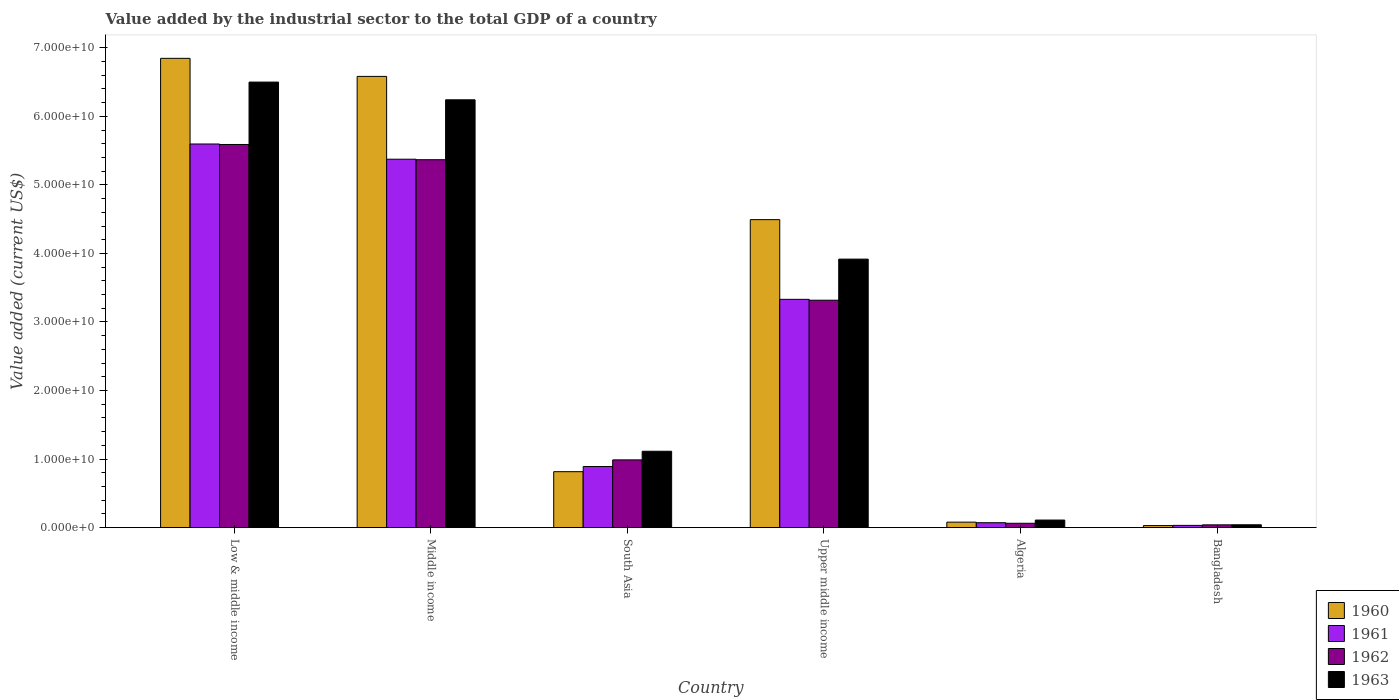How many groups of bars are there?
Offer a terse response. 6. Are the number of bars on each tick of the X-axis equal?
Offer a very short reply. Yes. How many bars are there on the 4th tick from the right?
Your answer should be compact. 4. What is the label of the 3rd group of bars from the left?
Offer a very short reply. South Asia. In how many cases, is the number of bars for a given country not equal to the number of legend labels?
Keep it short and to the point. 0. What is the value added by the industrial sector to the total GDP in 1960 in Algeria?
Provide a succinct answer. 8.00e+08. Across all countries, what is the maximum value added by the industrial sector to the total GDP in 1960?
Your answer should be very brief. 6.85e+1. Across all countries, what is the minimum value added by the industrial sector to the total GDP in 1963?
Keep it short and to the point. 4.15e+08. In which country was the value added by the industrial sector to the total GDP in 1963 maximum?
Provide a short and direct response. Low & middle income. What is the total value added by the industrial sector to the total GDP in 1963 in the graph?
Your answer should be very brief. 1.79e+11. What is the difference between the value added by the industrial sector to the total GDP in 1962 in Algeria and that in Upper middle income?
Provide a succinct answer. -3.25e+1. What is the difference between the value added by the industrial sector to the total GDP in 1963 in Upper middle income and the value added by the industrial sector to the total GDP in 1961 in Low & middle income?
Your answer should be compact. -1.68e+1. What is the average value added by the industrial sector to the total GDP in 1962 per country?
Make the answer very short. 2.56e+1. What is the difference between the value added by the industrial sector to the total GDP of/in 1961 and value added by the industrial sector to the total GDP of/in 1963 in South Asia?
Your answer should be compact. -2.23e+09. In how many countries, is the value added by the industrial sector to the total GDP in 1961 greater than 24000000000 US$?
Your answer should be very brief. 3. What is the ratio of the value added by the industrial sector to the total GDP in 1962 in Algeria to that in Upper middle income?
Provide a short and direct response. 0.02. Is the difference between the value added by the industrial sector to the total GDP in 1961 in Algeria and Middle income greater than the difference between the value added by the industrial sector to the total GDP in 1963 in Algeria and Middle income?
Make the answer very short. Yes. What is the difference between the highest and the second highest value added by the industrial sector to the total GDP in 1963?
Keep it short and to the point. 2.58e+1. What is the difference between the highest and the lowest value added by the industrial sector to the total GDP in 1960?
Your answer should be very brief. 6.82e+1. In how many countries, is the value added by the industrial sector to the total GDP in 1961 greater than the average value added by the industrial sector to the total GDP in 1961 taken over all countries?
Provide a succinct answer. 3. Is the sum of the value added by the industrial sector to the total GDP in 1961 in Algeria and Middle income greater than the maximum value added by the industrial sector to the total GDP in 1963 across all countries?
Offer a very short reply. No. Is it the case that in every country, the sum of the value added by the industrial sector to the total GDP in 1962 and value added by the industrial sector to the total GDP in 1961 is greater than the sum of value added by the industrial sector to the total GDP in 1960 and value added by the industrial sector to the total GDP in 1963?
Give a very brief answer. No. What does the 3rd bar from the right in Middle income represents?
Your answer should be very brief. 1961. How many bars are there?
Provide a succinct answer. 24. Are all the bars in the graph horizontal?
Provide a succinct answer. No. How many countries are there in the graph?
Provide a short and direct response. 6. Are the values on the major ticks of Y-axis written in scientific E-notation?
Keep it short and to the point. Yes. Does the graph contain grids?
Keep it short and to the point. No. Where does the legend appear in the graph?
Offer a very short reply. Bottom right. How many legend labels are there?
Offer a terse response. 4. How are the legend labels stacked?
Keep it short and to the point. Vertical. What is the title of the graph?
Your answer should be compact. Value added by the industrial sector to the total GDP of a country. What is the label or title of the X-axis?
Provide a succinct answer. Country. What is the label or title of the Y-axis?
Your answer should be compact. Value added (current US$). What is the Value added (current US$) of 1960 in Low & middle income?
Provide a short and direct response. 6.85e+1. What is the Value added (current US$) in 1961 in Low & middle income?
Give a very brief answer. 5.60e+1. What is the Value added (current US$) in 1962 in Low & middle income?
Provide a succinct answer. 5.59e+1. What is the Value added (current US$) of 1963 in Low & middle income?
Provide a succinct answer. 6.50e+1. What is the Value added (current US$) of 1960 in Middle income?
Your answer should be very brief. 6.58e+1. What is the Value added (current US$) in 1961 in Middle income?
Your response must be concise. 5.37e+1. What is the Value added (current US$) of 1962 in Middle income?
Make the answer very short. 5.37e+1. What is the Value added (current US$) in 1963 in Middle income?
Offer a very short reply. 6.24e+1. What is the Value added (current US$) of 1960 in South Asia?
Your answer should be compact. 8.16e+09. What is the Value added (current US$) in 1961 in South Asia?
Your answer should be compact. 8.91e+09. What is the Value added (current US$) in 1962 in South Asia?
Offer a very short reply. 9.88e+09. What is the Value added (current US$) of 1963 in South Asia?
Provide a short and direct response. 1.11e+1. What is the Value added (current US$) in 1960 in Upper middle income?
Your answer should be very brief. 4.49e+1. What is the Value added (current US$) of 1961 in Upper middle income?
Make the answer very short. 3.33e+1. What is the Value added (current US$) in 1962 in Upper middle income?
Make the answer very short. 3.32e+1. What is the Value added (current US$) in 1963 in Upper middle income?
Provide a succinct answer. 3.92e+1. What is the Value added (current US$) in 1960 in Algeria?
Your response must be concise. 8.00e+08. What is the Value added (current US$) of 1961 in Algeria?
Keep it short and to the point. 7.17e+08. What is the Value added (current US$) of 1962 in Algeria?
Your answer should be very brief. 6.34e+08. What is the Value added (current US$) in 1963 in Algeria?
Offer a terse response. 1.10e+09. What is the Value added (current US$) of 1960 in Bangladesh?
Offer a very short reply. 2.98e+08. What is the Value added (current US$) in 1961 in Bangladesh?
Your answer should be compact. 3.27e+08. What is the Value added (current US$) of 1962 in Bangladesh?
Provide a succinct answer. 4.05e+08. What is the Value added (current US$) of 1963 in Bangladesh?
Offer a very short reply. 4.15e+08. Across all countries, what is the maximum Value added (current US$) in 1960?
Provide a short and direct response. 6.85e+1. Across all countries, what is the maximum Value added (current US$) of 1961?
Give a very brief answer. 5.60e+1. Across all countries, what is the maximum Value added (current US$) in 1962?
Make the answer very short. 5.59e+1. Across all countries, what is the maximum Value added (current US$) in 1963?
Provide a short and direct response. 6.50e+1. Across all countries, what is the minimum Value added (current US$) of 1960?
Make the answer very short. 2.98e+08. Across all countries, what is the minimum Value added (current US$) in 1961?
Ensure brevity in your answer.  3.27e+08. Across all countries, what is the minimum Value added (current US$) of 1962?
Your answer should be very brief. 4.05e+08. Across all countries, what is the minimum Value added (current US$) in 1963?
Provide a succinct answer. 4.15e+08. What is the total Value added (current US$) in 1960 in the graph?
Your response must be concise. 1.88e+11. What is the total Value added (current US$) in 1961 in the graph?
Provide a succinct answer. 1.53e+11. What is the total Value added (current US$) in 1962 in the graph?
Your answer should be very brief. 1.54e+11. What is the total Value added (current US$) in 1963 in the graph?
Make the answer very short. 1.79e+11. What is the difference between the Value added (current US$) of 1960 in Low & middle income and that in Middle income?
Your response must be concise. 2.63e+09. What is the difference between the Value added (current US$) in 1961 in Low & middle income and that in Middle income?
Your answer should be very brief. 2.22e+09. What is the difference between the Value added (current US$) in 1962 in Low & middle income and that in Middle income?
Offer a terse response. 2.22e+09. What is the difference between the Value added (current US$) in 1963 in Low & middle income and that in Middle income?
Ensure brevity in your answer.  2.59e+09. What is the difference between the Value added (current US$) in 1960 in Low & middle income and that in South Asia?
Give a very brief answer. 6.03e+1. What is the difference between the Value added (current US$) of 1961 in Low & middle income and that in South Asia?
Keep it short and to the point. 4.71e+1. What is the difference between the Value added (current US$) of 1962 in Low & middle income and that in South Asia?
Provide a succinct answer. 4.60e+1. What is the difference between the Value added (current US$) in 1963 in Low & middle income and that in South Asia?
Provide a short and direct response. 5.39e+1. What is the difference between the Value added (current US$) of 1960 in Low & middle income and that in Upper middle income?
Offer a very short reply. 2.35e+1. What is the difference between the Value added (current US$) in 1961 in Low & middle income and that in Upper middle income?
Provide a short and direct response. 2.27e+1. What is the difference between the Value added (current US$) in 1962 in Low & middle income and that in Upper middle income?
Offer a very short reply. 2.27e+1. What is the difference between the Value added (current US$) in 1963 in Low & middle income and that in Upper middle income?
Provide a succinct answer. 2.58e+1. What is the difference between the Value added (current US$) of 1960 in Low & middle income and that in Algeria?
Ensure brevity in your answer.  6.77e+1. What is the difference between the Value added (current US$) in 1961 in Low & middle income and that in Algeria?
Offer a very short reply. 5.53e+1. What is the difference between the Value added (current US$) in 1962 in Low & middle income and that in Algeria?
Offer a very short reply. 5.53e+1. What is the difference between the Value added (current US$) in 1963 in Low & middle income and that in Algeria?
Provide a succinct answer. 6.39e+1. What is the difference between the Value added (current US$) of 1960 in Low & middle income and that in Bangladesh?
Your response must be concise. 6.82e+1. What is the difference between the Value added (current US$) of 1961 in Low & middle income and that in Bangladesh?
Provide a short and direct response. 5.56e+1. What is the difference between the Value added (current US$) of 1962 in Low & middle income and that in Bangladesh?
Offer a very short reply. 5.55e+1. What is the difference between the Value added (current US$) in 1963 in Low & middle income and that in Bangladesh?
Ensure brevity in your answer.  6.46e+1. What is the difference between the Value added (current US$) of 1960 in Middle income and that in South Asia?
Your answer should be compact. 5.77e+1. What is the difference between the Value added (current US$) of 1961 in Middle income and that in South Asia?
Your response must be concise. 4.48e+1. What is the difference between the Value added (current US$) in 1962 in Middle income and that in South Asia?
Provide a short and direct response. 4.38e+1. What is the difference between the Value added (current US$) of 1963 in Middle income and that in South Asia?
Keep it short and to the point. 5.13e+1. What is the difference between the Value added (current US$) in 1960 in Middle income and that in Upper middle income?
Provide a succinct answer. 2.09e+1. What is the difference between the Value added (current US$) of 1961 in Middle income and that in Upper middle income?
Offer a terse response. 2.04e+1. What is the difference between the Value added (current US$) in 1962 in Middle income and that in Upper middle income?
Ensure brevity in your answer.  2.05e+1. What is the difference between the Value added (current US$) of 1963 in Middle income and that in Upper middle income?
Offer a very short reply. 2.32e+1. What is the difference between the Value added (current US$) in 1960 in Middle income and that in Algeria?
Offer a terse response. 6.50e+1. What is the difference between the Value added (current US$) in 1961 in Middle income and that in Algeria?
Provide a succinct answer. 5.30e+1. What is the difference between the Value added (current US$) of 1962 in Middle income and that in Algeria?
Give a very brief answer. 5.30e+1. What is the difference between the Value added (current US$) in 1963 in Middle income and that in Algeria?
Give a very brief answer. 6.13e+1. What is the difference between the Value added (current US$) in 1960 in Middle income and that in Bangladesh?
Provide a succinct answer. 6.55e+1. What is the difference between the Value added (current US$) in 1961 in Middle income and that in Bangladesh?
Offer a terse response. 5.34e+1. What is the difference between the Value added (current US$) of 1962 in Middle income and that in Bangladesh?
Your answer should be very brief. 5.33e+1. What is the difference between the Value added (current US$) of 1963 in Middle income and that in Bangladesh?
Your response must be concise. 6.20e+1. What is the difference between the Value added (current US$) of 1960 in South Asia and that in Upper middle income?
Your answer should be very brief. -3.68e+1. What is the difference between the Value added (current US$) of 1961 in South Asia and that in Upper middle income?
Give a very brief answer. -2.44e+1. What is the difference between the Value added (current US$) in 1962 in South Asia and that in Upper middle income?
Your answer should be compact. -2.33e+1. What is the difference between the Value added (current US$) of 1963 in South Asia and that in Upper middle income?
Ensure brevity in your answer.  -2.80e+1. What is the difference between the Value added (current US$) of 1960 in South Asia and that in Algeria?
Provide a short and direct response. 7.36e+09. What is the difference between the Value added (current US$) of 1961 in South Asia and that in Algeria?
Your answer should be very brief. 8.20e+09. What is the difference between the Value added (current US$) of 1962 in South Asia and that in Algeria?
Make the answer very short. 9.25e+09. What is the difference between the Value added (current US$) of 1963 in South Asia and that in Algeria?
Your response must be concise. 1.00e+1. What is the difference between the Value added (current US$) of 1960 in South Asia and that in Bangladesh?
Offer a terse response. 7.86e+09. What is the difference between the Value added (current US$) in 1961 in South Asia and that in Bangladesh?
Your answer should be very brief. 8.59e+09. What is the difference between the Value added (current US$) in 1962 in South Asia and that in Bangladesh?
Make the answer very short. 9.48e+09. What is the difference between the Value added (current US$) in 1963 in South Asia and that in Bangladesh?
Offer a very short reply. 1.07e+1. What is the difference between the Value added (current US$) in 1960 in Upper middle income and that in Algeria?
Provide a succinct answer. 4.41e+1. What is the difference between the Value added (current US$) of 1961 in Upper middle income and that in Algeria?
Offer a very short reply. 3.26e+1. What is the difference between the Value added (current US$) of 1962 in Upper middle income and that in Algeria?
Keep it short and to the point. 3.25e+1. What is the difference between the Value added (current US$) in 1963 in Upper middle income and that in Algeria?
Provide a succinct answer. 3.81e+1. What is the difference between the Value added (current US$) of 1960 in Upper middle income and that in Bangladesh?
Your response must be concise. 4.46e+1. What is the difference between the Value added (current US$) of 1961 in Upper middle income and that in Bangladesh?
Make the answer very short. 3.30e+1. What is the difference between the Value added (current US$) in 1962 in Upper middle income and that in Bangladesh?
Ensure brevity in your answer.  3.28e+1. What is the difference between the Value added (current US$) of 1963 in Upper middle income and that in Bangladesh?
Give a very brief answer. 3.88e+1. What is the difference between the Value added (current US$) in 1960 in Algeria and that in Bangladesh?
Your response must be concise. 5.02e+08. What is the difference between the Value added (current US$) of 1961 in Algeria and that in Bangladesh?
Keep it short and to the point. 3.90e+08. What is the difference between the Value added (current US$) in 1962 in Algeria and that in Bangladesh?
Your answer should be compact. 2.30e+08. What is the difference between the Value added (current US$) of 1963 in Algeria and that in Bangladesh?
Your answer should be very brief. 6.88e+08. What is the difference between the Value added (current US$) in 1960 in Low & middle income and the Value added (current US$) in 1961 in Middle income?
Provide a succinct answer. 1.47e+1. What is the difference between the Value added (current US$) in 1960 in Low & middle income and the Value added (current US$) in 1962 in Middle income?
Your answer should be very brief. 1.48e+1. What is the difference between the Value added (current US$) of 1960 in Low & middle income and the Value added (current US$) of 1963 in Middle income?
Keep it short and to the point. 6.05e+09. What is the difference between the Value added (current US$) of 1961 in Low & middle income and the Value added (current US$) of 1962 in Middle income?
Offer a terse response. 2.29e+09. What is the difference between the Value added (current US$) in 1961 in Low & middle income and the Value added (current US$) in 1963 in Middle income?
Provide a short and direct response. -6.45e+09. What is the difference between the Value added (current US$) of 1962 in Low & middle income and the Value added (current US$) of 1963 in Middle income?
Your answer should be very brief. -6.52e+09. What is the difference between the Value added (current US$) in 1960 in Low & middle income and the Value added (current US$) in 1961 in South Asia?
Provide a succinct answer. 5.96e+1. What is the difference between the Value added (current US$) of 1960 in Low & middle income and the Value added (current US$) of 1962 in South Asia?
Provide a short and direct response. 5.86e+1. What is the difference between the Value added (current US$) in 1960 in Low & middle income and the Value added (current US$) in 1963 in South Asia?
Give a very brief answer. 5.73e+1. What is the difference between the Value added (current US$) of 1961 in Low & middle income and the Value added (current US$) of 1962 in South Asia?
Your answer should be very brief. 4.61e+1. What is the difference between the Value added (current US$) of 1961 in Low & middle income and the Value added (current US$) of 1963 in South Asia?
Offer a very short reply. 4.48e+1. What is the difference between the Value added (current US$) in 1962 in Low & middle income and the Value added (current US$) in 1963 in South Asia?
Keep it short and to the point. 4.48e+1. What is the difference between the Value added (current US$) in 1960 in Low & middle income and the Value added (current US$) in 1961 in Upper middle income?
Ensure brevity in your answer.  3.52e+1. What is the difference between the Value added (current US$) of 1960 in Low & middle income and the Value added (current US$) of 1962 in Upper middle income?
Provide a short and direct response. 3.53e+1. What is the difference between the Value added (current US$) of 1960 in Low & middle income and the Value added (current US$) of 1963 in Upper middle income?
Your answer should be very brief. 2.93e+1. What is the difference between the Value added (current US$) of 1961 in Low & middle income and the Value added (current US$) of 1962 in Upper middle income?
Your answer should be very brief. 2.28e+1. What is the difference between the Value added (current US$) of 1961 in Low & middle income and the Value added (current US$) of 1963 in Upper middle income?
Your response must be concise. 1.68e+1. What is the difference between the Value added (current US$) of 1962 in Low & middle income and the Value added (current US$) of 1963 in Upper middle income?
Ensure brevity in your answer.  1.67e+1. What is the difference between the Value added (current US$) in 1960 in Low & middle income and the Value added (current US$) in 1961 in Algeria?
Keep it short and to the point. 6.77e+1. What is the difference between the Value added (current US$) of 1960 in Low & middle income and the Value added (current US$) of 1962 in Algeria?
Your answer should be very brief. 6.78e+1. What is the difference between the Value added (current US$) in 1960 in Low & middle income and the Value added (current US$) in 1963 in Algeria?
Ensure brevity in your answer.  6.74e+1. What is the difference between the Value added (current US$) of 1961 in Low & middle income and the Value added (current US$) of 1962 in Algeria?
Your answer should be very brief. 5.53e+1. What is the difference between the Value added (current US$) in 1961 in Low & middle income and the Value added (current US$) in 1963 in Algeria?
Give a very brief answer. 5.49e+1. What is the difference between the Value added (current US$) of 1962 in Low & middle income and the Value added (current US$) of 1963 in Algeria?
Make the answer very short. 5.48e+1. What is the difference between the Value added (current US$) of 1960 in Low & middle income and the Value added (current US$) of 1961 in Bangladesh?
Make the answer very short. 6.81e+1. What is the difference between the Value added (current US$) of 1960 in Low & middle income and the Value added (current US$) of 1962 in Bangladesh?
Offer a terse response. 6.81e+1. What is the difference between the Value added (current US$) in 1960 in Low & middle income and the Value added (current US$) in 1963 in Bangladesh?
Ensure brevity in your answer.  6.81e+1. What is the difference between the Value added (current US$) in 1961 in Low & middle income and the Value added (current US$) in 1962 in Bangladesh?
Give a very brief answer. 5.56e+1. What is the difference between the Value added (current US$) of 1961 in Low & middle income and the Value added (current US$) of 1963 in Bangladesh?
Your answer should be very brief. 5.56e+1. What is the difference between the Value added (current US$) of 1962 in Low & middle income and the Value added (current US$) of 1963 in Bangladesh?
Offer a very short reply. 5.55e+1. What is the difference between the Value added (current US$) in 1960 in Middle income and the Value added (current US$) in 1961 in South Asia?
Keep it short and to the point. 5.69e+1. What is the difference between the Value added (current US$) of 1960 in Middle income and the Value added (current US$) of 1962 in South Asia?
Your answer should be very brief. 5.59e+1. What is the difference between the Value added (current US$) in 1960 in Middle income and the Value added (current US$) in 1963 in South Asia?
Offer a very short reply. 5.47e+1. What is the difference between the Value added (current US$) in 1961 in Middle income and the Value added (current US$) in 1962 in South Asia?
Your answer should be compact. 4.39e+1. What is the difference between the Value added (current US$) of 1961 in Middle income and the Value added (current US$) of 1963 in South Asia?
Your answer should be very brief. 4.26e+1. What is the difference between the Value added (current US$) of 1962 in Middle income and the Value added (current US$) of 1963 in South Asia?
Keep it short and to the point. 4.25e+1. What is the difference between the Value added (current US$) in 1960 in Middle income and the Value added (current US$) in 1961 in Upper middle income?
Make the answer very short. 3.25e+1. What is the difference between the Value added (current US$) of 1960 in Middle income and the Value added (current US$) of 1962 in Upper middle income?
Keep it short and to the point. 3.27e+1. What is the difference between the Value added (current US$) of 1960 in Middle income and the Value added (current US$) of 1963 in Upper middle income?
Offer a very short reply. 2.67e+1. What is the difference between the Value added (current US$) in 1961 in Middle income and the Value added (current US$) in 1962 in Upper middle income?
Give a very brief answer. 2.06e+1. What is the difference between the Value added (current US$) in 1961 in Middle income and the Value added (current US$) in 1963 in Upper middle income?
Give a very brief answer. 1.46e+1. What is the difference between the Value added (current US$) in 1962 in Middle income and the Value added (current US$) in 1963 in Upper middle income?
Your answer should be compact. 1.45e+1. What is the difference between the Value added (current US$) in 1960 in Middle income and the Value added (current US$) in 1961 in Algeria?
Offer a terse response. 6.51e+1. What is the difference between the Value added (current US$) of 1960 in Middle income and the Value added (current US$) of 1962 in Algeria?
Provide a short and direct response. 6.52e+1. What is the difference between the Value added (current US$) in 1960 in Middle income and the Value added (current US$) in 1963 in Algeria?
Give a very brief answer. 6.47e+1. What is the difference between the Value added (current US$) in 1961 in Middle income and the Value added (current US$) in 1962 in Algeria?
Ensure brevity in your answer.  5.31e+1. What is the difference between the Value added (current US$) in 1961 in Middle income and the Value added (current US$) in 1963 in Algeria?
Give a very brief answer. 5.26e+1. What is the difference between the Value added (current US$) in 1962 in Middle income and the Value added (current US$) in 1963 in Algeria?
Your response must be concise. 5.26e+1. What is the difference between the Value added (current US$) of 1960 in Middle income and the Value added (current US$) of 1961 in Bangladesh?
Your response must be concise. 6.55e+1. What is the difference between the Value added (current US$) in 1960 in Middle income and the Value added (current US$) in 1962 in Bangladesh?
Your answer should be compact. 6.54e+1. What is the difference between the Value added (current US$) of 1960 in Middle income and the Value added (current US$) of 1963 in Bangladesh?
Give a very brief answer. 6.54e+1. What is the difference between the Value added (current US$) in 1961 in Middle income and the Value added (current US$) in 1962 in Bangladesh?
Your answer should be very brief. 5.33e+1. What is the difference between the Value added (current US$) in 1961 in Middle income and the Value added (current US$) in 1963 in Bangladesh?
Offer a terse response. 5.33e+1. What is the difference between the Value added (current US$) of 1962 in Middle income and the Value added (current US$) of 1963 in Bangladesh?
Provide a short and direct response. 5.33e+1. What is the difference between the Value added (current US$) of 1960 in South Asia and the Value added (current US$) of 1961 in Upper middle income?
Keep it short and to the point. -2.51e+1. What is the difference between the Value added (current US$) in 1960 in South Asia and the Value added (current US$) in 1962 in Upper middle income?
Ensure brevity in your answer.  -2.50e+1. What is the difference between the Value added (current US$) of 1960 in South Asia and the Value added (current US$) of 1963 in Upper middle income?
Your response must be concise. -3.10e+1. What is the difference between the Value added (current US$) in 1961 in South Asia and the Value added (current US$) in 1962 in Upper middle income?
Your answer should be compact. -2.43e+1. What is the difference between the Value added (current US$) in 1961 in South Asia and the Value added (current US$) in 1963 in Upper middle income?
Your answer should be very brief. -3.03e+1. What is the difference between the Value added (current US$) of 1962 in South Asia and the Value added (current US$) of 1963 in Upper middle income?
Ensure brevity in your answer.  -2.93e+1. What is the difference between the Value added (current US$) in 1960 in South Asia and the Value added (current US$) in 1961 in Algeria?
Offer a terse response. 7.44e+09. What is the difference between the Value added (current US$) of 1960 in South Asia and the Value added (current US$) of 1962 in Algeria?
Your answer should be compact. 7.53e+09. What is the difference between the Value added (current US$) of 1960 in South Asia and the Value added (current US$) of 1963 in Algeria?
Provide a succinct answer. 7.06e+09. What is the difference between the Value added (current US$) of 1961 in South Asia and the Value added (current US$) of 1962 in Algeria?
Give a very brief answer. 8.28e+09. What is the difference between the Value added (current US$) of 1961 in South Asia and the Value added (current US$) of 1963 in Algeria?
Your response must be concise. 7.81e+09. What is the difference between the Value added (current US$) of 1962 in South Asia and the Value added (current US$) of 1963 in Algeria?
Make the answer very short. 8.78e+09. What is the difference between the Value added (current US$) in 1960 in South Asia and the Value added (current US$) in 1961 in Bangladesh?
Offer a terse response. 7.83e+09. What is the difference between the Value added (current US$) of 1960 in South Asia and the Value added (current US$) of 1962 in Bangladesh?
Provide a succinct answer. 7.76e+09. What is the difference between the Value added (current US$) in 1960 in South Asia and the Value added (current US$) in 1963 in Bangladesh?
Your answer should be compact. 7.75e+09. What is the difference between the Value added (current US$) of 1961 in South Asia and the Value added (current US$) of 1962 in Bangladesh?
Ensure brevity in your answer.  8.51e+09. What is the difference between the Value added (current US$) of 1961 in South Asia and the Value added (current US$) of 1963 in Bangladesh?
Your answer should be very brief. 8.50e+09. What is the difference between the Value added (current US$) in 1962 in South Asia and the Value added (current US$) in 1963 in Bangladesh?
Offer a terse response. 9.47e+09. What is the difference between the Value added (current US$) of 1960 in Upper middle income and the Value added (current US$) of 1961 in Algeria?
Ensure brevity in your answer.  4.42e+1. What is the difference between the Value added (current US$) of 1960 in Upper middle income and the Value added (current US$) of 1962 in Algeria?
Your answer should be very brief. 4.43e+1. What is the difference between the Value added (current US$) in 1960 in Upper middle income and the Value added (current US$) in 1963 in Algeria?
Make the answer very short. 4.38e+1. What is the difference between the Value added (current US$) of 1961 in Upper middle income and the Value added (current US$) of 1962 in Algeria?
Provide a succinct answer. 3.27e+1. What is the difference between the Value added (current US$) in 1961 in Upper middle income and the Value added (current US$) in 1963 in Algeria?
Your answer should be very brief. 3.22e+1. What is the difference between the Value added (current US$) in 1962 in Upper middle income and the Value added (current US$) in 1963 in Algeria?
Make the answer very short. 3.21e+1. What is the difference between the Value added (current US$) in 1960 in Upper middle income and the Value added (current US$) in 1961 in Bangladesh?
Ensure brevity in your answer.  4.46e+1. What is the difference between the Value added (current US$) in 1960 in Upper middle income and the Value added (current US$) in 1962 in Bangladesh?
Make the answer very short. 4.45e+1. What is the difference between the Value added (current US$) of 1960 in Upper middle income and the Value added (current US$) of 1963 in Bangladesh?
Your answer should be compact. 4.45e+1. What is the difference between the Value added (current US$) of 1961 in Upper middle income and the Value added (current US$) of 1962 in Bangladesh?
Offer a very short reply. 3.29e+1. What is the difference between the Value added (current US$) in 1961 in Upper middle income and the Value added (current US$) in 1963 in Bangladesh?
Your response must be concise. 3.29e+1. What is the difference between the Value added (current US$) in 1962 in Upper middle income and the Value added (current US$) in 1963 in Bangladesh?
Your response must be concise. 3.28e+1. What is the difference between the Value added (current US$) in 1960 in Algeria and the Value added (current US$) in 1961 in Bangladesh?
Provide a succinct answer. 4.73e+08. What is the difference between the Value added (current US$) in 1960 in Algeria and the Value added (current US$) in 1962 in Bangladesh?
Provide a short and direct response. 3.95e+08. What is the difference between the Value added (current US$) in 1960 in Algeria and the Value added (current US$) in 1963 in Bangladesh?
Your answer should be very brief. 3.85e+08. What is the difference between the Value added (current US$) of 1961 in Algeria and the Value added (current US$) of 1962 in Bangladesh?
Your answer should be very brief. 3.12e+08. What is the difference between the Value added (current US$) of 1961 in Algeria and the Value added (current US$) of 1963 in Bangladesh?
Your answer should be very brief. 3.02e+08. What is the difference between the Value added (current US$) of 1962 in Algeria and the Value added (current US$) of 1963 in Bangladesh?
Provide a short and direct response. 2.19e+08. What is the average Value added (current US$) of 1960 per country?
Your answer should be compact. 3.14e+1. What is the average Value added (current US$) in 1961 per country?
Your answer should be compact. 2.55e+1. What is the average Value added (current US$) of 1962 per country?
Ensure brevity in your answer.  2.56e+1. What is the average Value added (current US$) of 1963 per country?
Offer a very short reply. 2.99e+1. What is the difference between the Value added (current US$) of 1960 and Value added (current US$) of 1961 in Low & middle income?
Provide a succinct answer. 1.25e+1. What is the difference between the Value added (current US$) in 1960 and Value added (current US$) in 1962 in Low & middle income?
Ensure brevity in your answer.  1.26e+1. What is the difference between the Value added (current US$) of 1960 and Value added (current US$) of 1963 in Low & middle income?
Ensure brevity in your answer.  3.46e+09. What is the difference between the Value added (current US$) in 1961 and Value added (current US$) in 1962 in Low & middle income?
Your answer should be very brief. 7.11e+07. What is the difference between the Value added (current US$) in 1961 and Value added (current US$) in 1963 in Low & middle income?
Provide a short and direct response. -9.03e+09. What is the difference between the Value added (current US$) of 1962 and Value added (current US$) of 1963 in Low & middle income?
Provide a short and direct response. -9.10e+09. What is the difference between the Value added (current US$) in 1960 and Value added (current US$) in 1961 in Middle income?
Ensure brevity in your answer.  1.21e+1. What is the difference between the Value added (current US$) of 1960 and Value added (current US$) of 1962 in Middle income?
Offer a very short reply. 1.22e+1. What is the difference between the Value added (current US$) in 1960 and Value added (current US$) in 1963 in Middle income?
Provide a short and direct response. 3.41e+09. What is the difference between the Value added (current US$) in 1961 and Value added (current US$) in 1962 in Middle income?
Provide a succinct answer. 7.12e+07. What is the difference between the Value added (current US$) of 1961 and Value added (current US$) of 1963 in Middle income?
Ensure brevity in your answer.  -8.67e+09. What is the difference between the Value added (current US$) in 1962 and Value added (current US$) in 1963 in Middle income?
Offer a terse response. -8.74e+09. What is the difference between the Value added (current US$) of 1960 and Value added (current US$) of 1961 in South Asia?
Your answer should be compact. -7.53e+08. What is the difference between the Value added (current US$) in 1960 and Value added (current US$) in 1962 in South Asia?
Make the answer very short. -1.72e+09. What is the difference between the Value added (current US$) in 1960 and Value added (current US$) in 1963 in South Asia?
Your response must be concise. -2.98e+09. What is the difference between the Value added (current US$) of 1961 and Value added (current US$) of 1962 in South Asia?
Ensure brevity in your answer.  -9.68e+08. What is the difference between the Value added (current US$) of 1961 and Value added (current US$) of 1963 in South Asia?
Keep it short and to the point. -2.23e+09. What is the difference between the Value added (current US$) of 1962 and Value added (current US$) of 1963 in South Asia?
Provide a short and direct response. -1.26e+09. What is the difference between the Value added (current US$) of 1960 and Value added (current US$) of 1961 in Upper middle income?
Your answer should be compact. 1.16e+1. What is the difference between the Value added (current US$) in 1960 and Value added (current US$) in 1962 in Upper middle income?
Make the answer very short. 1.18e+1. What is the difference between the Value added (current US$) of 1960 and Value added (current US$) of 1963 in Upper middle income?
Offer a terse response. 5.76e+09. What is the difference between the Value added (current US$) in 1961 and Value added (current US$) in 1962 in Upper middle income?
Your answer should be compact. 1.26e+08. What is the difference between the Value added (current US$) of 1961 and Value added (current US$) of 1963 in Upper middle income?
Make the answer very short. -5.87e+09. What is the difference between the Value added (current US$) in 1962 and Value added (current US$) in 1963 in Upper middle income?
Provide a short and direct response. -5.99e+09. What is the difference between the Value added (current US$) of 1960 and Value added (current US$) of 1961 in Algeria?
Your answer should be very brief. 8.27e+07. What is the difference between the Value added (current US$) of 1960 and Value added (current US$) of 1962 in Algeria?
Ensure brevity in your answer.  1.65e+08. What is the difference between the Value added (current US$) of 1960 and Value added (current US$) of 1963 in Algeria?
Make the answer very short. -3.03e+08. What is the difference between the Value added (current US$) of 1961 and Value added (current US$) of 1962 in Algeria?
Make the answer very short. 8.27e+07. What is the difference between the Value added (current US$) of 1961 and Value added (current US$) of 1963 in Algeria?
Your answer should be compact. -3.86e+08. What is the difference between the Value added (current US$) in 1962 and Value added (current US$) in 1963 in Algeria?
Ensure brevity in your answer.  -4.69e+08. What is the difference between the Value added (current US$) of 1960 and Value added (current US$) of 1961 in Bangladesh?
Your answer should be compact. -2.92e+07. What is the difference between the Value added (current US$) of 1960 and Value added (current US$) of 1962 in Bangladesh?
Ensure brevity in your answer.  -1.07e+08. What is the difference between the Value added (current US$) in 1960 and Value added (current US$) in 1963 in Bangladesh?
Make the answer very short. -1.17e+08. What is the difference between the Value added (current US$) of 1961 and Value added (current US$) of 1962 in Bangladesh?
Ensure brevity in your answer.  -7.74e+07. What is the difference between the Value added (current US$) in 1961 and Value added (current US$) in 1963 in Bangladesh?
Offer a very short reply. -8.78e+07. What is the difference between the Value added (current US$) in 1962 and Value added (current US$) in 1963 in Bangladesh?
Your answer should be very brief. -1.05e+07. What is the ratio of the Value added (current US$) of 1961 in Low & middle income to that in Middle income?
Your answer should be very brief. 1.04. What is the ratio of the Value added (current US$) in 1962 in Low & middle income to that in Middle income?
Offer a terse response. 1.04. What is the ratio of the Value added (current US$) in 1963 in Low & middle income to that in Middle income?
Your answer should be compact. 1.04. What is the ratio of the Value added (current US$) in 1960 in Low & middle income to that in South Asia?
Your answer should be compact. 8.39. What is the ratio of the Value added (current US$) of 1961 in Low & middle income to that in South Asia?
Offer a terse response. 6.28. What is the ratio of the Value added (current US$) of 1962 in Low & middle income to that in South Asia?
Provide a short and direct response. 5.66. What is the ratio of the Value added (current US$) in 1963 in Low & middle income to that in South Asia?
Keep it short and to the point. 5.83. What is the ratio of the Value added (current US$) of 1960 in Low & middle income to that in Upper middle income?
Give a very brief answer. 1.52. What is the ratio of the Value added (current US$) of 1961 in Low & middle income to that in Upper middle income?
Make the answer very short. 1.68. What is the ratio of the Value added (current US$) of 1962 in Low & middle income to that in Upper middle income?
Make the answer very short. 1.68. What is the ratio of the Value added (current US$) in 1963 in Low & middle income to that in Upper middle income?
Provide a short and direct response. 1.66. What is the ratio of the Value added (current US$) in 1960 in Low & middle income to that in Algeria?
Ensure brevity in your answer.  85.59. What is the ratio of the Value added (current US$) of 1961 in Low & middle income to that in Algeria?
Provide a succinct answer. 78.04. What is the ratio of the Value added (current US$) of 1962 in Low & middle income to that in Algeria?
Your response must be concise. 88.11. What is the ratio of the Value added (current US$) in 1963 in Low & middle income to that in Algeria?
Keep it short and to the point. 58.91. What is the ratio of the Value added (current US$) of 1960 in Low & middle income to that in Bangladesh?
Your response must be concise. 229.65. What is the ratio of the Value added (current US$) of 1961 in Low & middle income to that in Bangladesh?
Offer a terse response. 171. What is the ratio of the Value added (current US$) of 1962 in Low & middle income to that in Bangladesh?
Give a very brief answer. 138.13. What is the ratio of the Value added (current US$) of 1963 in Low & middle income to that in Bangladesh?
Your response must be concise. 156.57. What is the ratio of the Value added (current US$) in 1960 in Middle income to that in South Asia?
Offer a terse response. 8.07. What is the ratio of the Value added (current US$) in 1961 in Middle income to that in South Asia?
Offer a very short reply. 6.03. What is the ratio of the Value added (current US$) in 1962 in Middle income to that in South Asia?
Keep it short and to the point. 5.43. What is the ratio of the Value added (current US$) of 1963 in Middle income to that in South Asia?
Offer a very short reply. 5.6. What is the ratio of the Value added (current US$) in 1960 in Middle income to that in Upper middle income?
Your answer should be compact. 1.47. What is the ratio of the Value added (current US$) of 1961 in Middle income to that in Upper middle income?
Offer a very short reply. 1.61. What is the ratio of the Value added (current US$) of 1962 in Middle income to that in Upper middle income?
Ensure brevity in your answer.  1.62. What is the ratio of the Value added (current US$) of 1963 in Middle income to that in Upper middle income?
Make the answer very short. 1.59. What is the ratio of the Value added (current US$) in 1960 in Middle income to that in Algeria?
Provide a succinct answer. 82.3. What is the ratio of the Value added (current US$) in 1961 in Middle income to that in Algeria?
Provide a short and direct response. 74.95. What is the ratio of the Value added (current US$) of 1962 in Middle income to that in Algeria?
Provide a short and direct response. 84.61. What is the ratio of the Value added (current US$) in 1963 in Middle income to that in Algeria?
Your answer should be compact. 56.57. What is the ratio of the Value added (current US$) in 1960 in Middle income to that in Bangladesh?
Provide a short and direct response. 220.82. What is the ratio of the Value added (current US$) of 1961 in Middle income to that in Bangladesh?
Ensure brevity in your answer.  164.21. What is the ratio of the Value added (current US$) in 1962 in Middle income to that in Bangladesh?
Ensure brevity in your answer.  132.64. What is the ratio of the Value added (current US$) of 1963 in Middle income to that in Bangladesh?
Your answer should be very brief. 150.34. What is the ratio of the Value added (current US$) of 1960 in South Asia to that in Upper middle income?
Keep it short and to the point. 0.18. What is the ratio of the Value added (current US$) in 1961 in South Asia to that in Upper middle income?
Provide a short and direct response. 0.27. What is the ratio of the Value added (current US$) of 1962 in South Asia to that in Upper middle income?
Offer a very short reply. 0.3. What is the ratio of the Value added (current US$) in 1963 in South Asia to that in Upper middle income?
Your response must be concise. 0.28. What is the ratio of the Value added (current US$) in 1960 in South Asia to that in Algeria?
Your response must be concise. 10.2. What is the ratio of the Value added (current US$) in 1961 in South Asia to that in Algeria?
Offer a very short reply. 12.43. What is the ratio of the Value added (current US$) in 1962 in South Asia to that in Algeria?
Ensure brevity in your answer.  15.58. What is the ratio of the Value added (current US$) of 1963 in South Asia to that in Algeria?
Your answer should be compact. 10.1. What is the ratio of the Value added (current US$) in 1960 in South Asia to that in Bangladesh?
Provide a short and direct response. 27.38. What is the ratio of the Value added (current US$) of 1961 in South Asia to that in Bangladesh?
Your answer should be very brief. 27.24. What is the ratio of the Value added (current US$) of 1962 in South Asia to that in Bangladesh?
Your response must be concise. 24.42. What is the ratio of the Value added (current US$) in 1963 in South Asia to that in Bangladesh?
Ensure brevity in your answer.  26.84. What is the ratio of the Value added (current US$) in 1960 in Upper middle income to that in Algeria?
Keep it short and to the point. 56.17. What is the ratio of the Value added (current US$) in 1961 in Upper middle income to that in Algeria?
Provide a short and direct response. 46.44. What is the ratio of the Value added (current US$) of 1962 in Upper middle income to that in Algeria?
Give a very brief answer. 52.3. What is the ratio of the Value added (current US$) of 1963 in Upper middle income to that in Algeria?
Keep it short and to the point. 35.5. What is the ratio of the Value added (current US$) of 1960 in Upper middle income to that in Bangladesh?
Offer a terse response. 150.72. What is the ratio of the Value added (current US$) in 1961 in Upper middle income to that in Bangladesh?
Give a very brief answer. 101.75. What is the ratio of the Value added (current US$) of 1962 in Upper middle income to that in Bangladesh?
Ensure brevity in your answer.  81.99. What is the ratio of the Value added (current US$) of 1963 in Upper middle income to that in Bangladesh?
Provide a succinct answer. 94.36. What is the ratio of the Value added (current US$) in 1960 in Algeria to that in Bangladesh?
Give a very brief answer. 2.68. What is the ratio of the Value added (current US$) of 1961 in Algeria to that in Bangladesh?
Your response must be concise. 2.19. What is the ratio of the Value added (current US$) in 1962 in Algeria to that in Bangladesh?
Your answer should be compact. 1.57. What is the ratio of the Value added (current US$) of 1963 in Algeria to that in Bangladesh?
Give a very brief answer. 2.66. What is the difference between the highest and the second highest Value added (current US$) of 1960?
Offer a terse response. 2.63e+09. What is the difference between the highest and the second highest Value added (current US$) in 1961?
Keep it short and to the point. 2.22e+09. What is the difference between the highest and the second highest Value added (current US$) of 1962?
Your answer should be compact. 2.22e+09. What is the difference between the highest and the second highest Value added (current US$) in 1963?
Ensure brevity in your answer.  2.59e+09. What is the difference between the highest and the lowest Value added (current US$) of 1960?
Provide a short and direct response. 6.82e+1. What is the difference between the highest and the lowest Value added (current US$) in 1961?
Your answer should be very brief. 5.56e+1. What is the difference between the highest and the lowest Value added (current US$) of 1962?
Give a very brief answer. 5.55e+1. What is the difference between the highest and the lowest Value added (current US$) in 1963?
Your answer should be compact. 6.46e+1. 